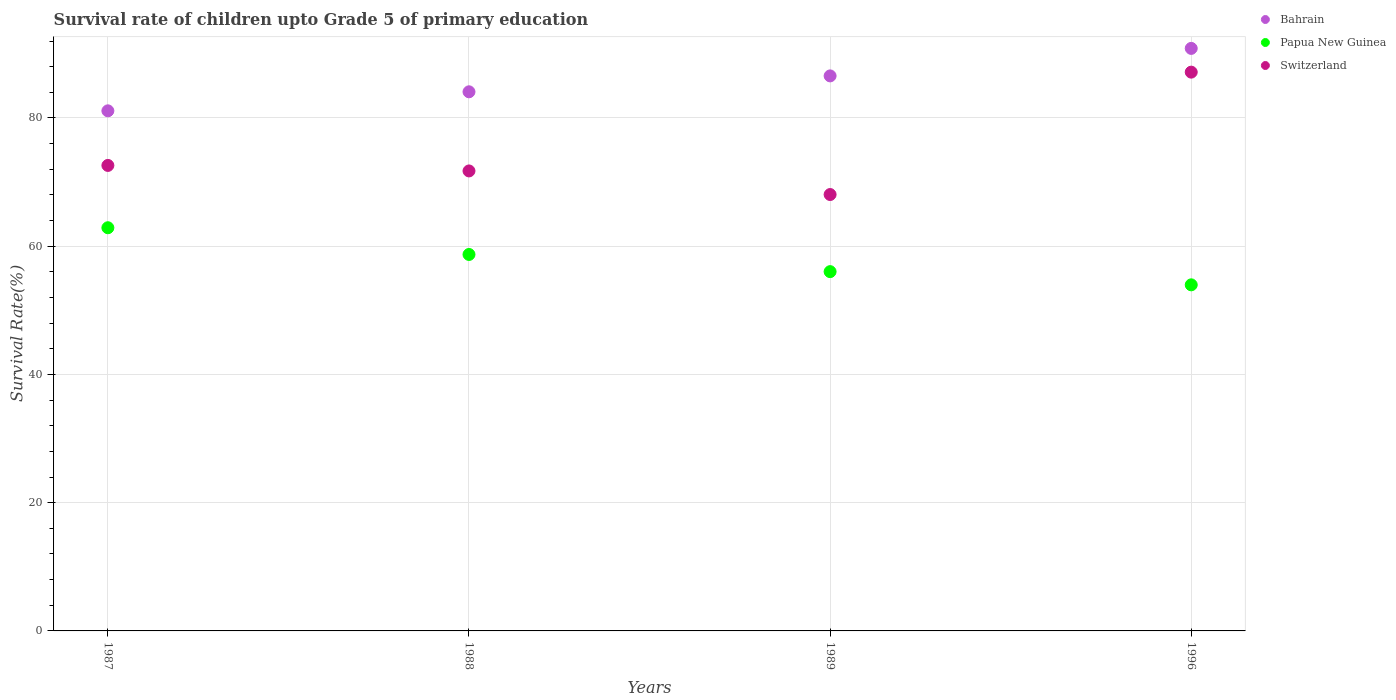How many different coloured dotlines are there?
Provide a succinct answer. 3. What is the survival rate of children in Papua New Guinea in 1996?
Your response must be concise. 53.97. Across all years, what is the maximum survival rate of children in Papua New Guinea?
Offer a very short reply. 62.88. Across all years, what is the minimum survival rate of children in Switzerland?
Offer a terse response. 68.06. In which year was the survival rate of children in Papua New Guinea maximum?
Ensure brevity in your answer.  1987. In which year was the survival rate of children in Papua New Guinea minimum?
Provide a succinct answer. 1996. What is the total survival rate of children in Switzerland in the graph?
Give a very brief answer. 299.54. What is the difference between the survival rate of children in Papua New Guinea in 1989 and that in 1996?
Keep it short and to the point. 2.06. What is the difference between the survival rate of children in Bahrain in 1988 and the survival rate of children in Papua New Guinea in 1987?
Provide a short and direct response. 21.2. What is the average survival rate of children in Switzerland per year?
Provide a succinct answer. 74.89. In the year 1987, what is the difference between the survival rate of children in Switzerland and survival rate of children in Bahrain?
Keep it short and to the point. -8.52. In how many years, is the survival rate of children in Bahrain greater than 4 %?
Offer a terse response. 4. What is the ratio of the survival rate of children in Bahrain in 1987 to that in 1988?
Your response must be concise. 0.96. Is the difference between the survival rate of children in Switzerland in 1988 and 1996 greater than the difference between the survival rate of children in Bahrain in 1988 and 1996?
Your answer should be very brief. No. What is the difference between the highest and the second highest survival rate of children in Switzerland?
Your answer should be very brief. 14.55. What is the difference between the highest and the lowest survival rate of children in Bahrain?
Give a very brief answer. 9.74. In how many years, is the survival rate of children in Papua New Guinea greater than the average survival rate of children in Papua New Guinea taken over all years?
Provide a short and direct response. 2. Is the sum of the survival rate of children in Switzerland in 1988 and 1989 greater than the maximum survival rate of children in Bahrain across all years?
Ensure brevity in your answer.  Yes. Does the survival rate of children in Switzerland monotonically increase over the years?
Make the answer very short. No. Does the graph contain any zero values?
Provide a short and direct response. No. Where does the legend appear in the graph?
Your answer should be compact. Top right. How many legend labels are there?
Make the answer very short. 3. What is the title of the graph?
Your answer should be compact. Survival rate of children upto Grade 5 of primary education. Does "Grenada" appear as one of the legend labels in the graph?
Ensure brevity in your answer.  No. What is the label or title of the Y-axis?
Make the answer very short. Survival Rate(%). What is the Survival Rate(%) of Bahrain in 1987?
Your response must be concise. 81.11. What is the Survival Rate(%) in Papua New Guinea in 1987?
Your answer should be very brief. 62.88. What is the Survival Rate(%) in Switzerland in 1987?
Offer a very short reply. 72.6. What is the Survival Rate(%) of Bahrain in 1988?
Offer a very short reply. 84.08. What is the Survival Rate(%) of Papua New Guinea in 1988?
Your response must be concise. 58.71. What is the Survival Rate(%) in Switzerland in 1988?
Offer a very short reply. 71.74. What is the Survival Rate(%) in Bahrain in 1989?
Give a very brief answer. 86.56. What is the Survival Rate(%) of Papua New Guinea in 1989?
Provide a short and direct response. 56.03. What is the Survival Rate(%) in Switzerland in 1989?
Your answer should be very brief. 68.06. What is the Survival Rate(%) of Bahrain in 1996?
Provide a short and direct response. 90.85. What is the Survival Rate(%) of Papua New Guinea in 1996?
Your response must be concise. 53.97. What is the Survival Rate(%) of Switzerland in 1996?
Your answer should be very brief. 87.15. Across all years, what is the maximum Survival Rate(%) in Bahrain?
Provide a succinct answer. 90.85. Across all years, what is the maximum Survival Rate(%) of Papua New Guinea?
Provide a short and direct response. 62.88. Across all years, what is the maximum Survival Rate(%) of Switzerland?
Make the answer very short. 87.15. Across all years, what is the minimum Survival Rate(%) in Bahrain?
Your response must be concise. 81.11. Across all years, what is the minimum Survival Rate(%) of Papua New Guinea?
Offer a terse response. 53.97. Across all years, what is the minimum Survival Rate(%) in Switzerland?
Offer a very short reply. 68.06. What is the total Survival Rate(%) in Bahrain in the graph?
Give a very brief answer. 342.6. What is the total Survival Rate(%) of Papua New Guinea in the graph?
Your response must be concise. 231.6. What is the total Survival Rate(%) in Switzerland in the graph?
Make the answer very short. 299.54. What is the difference between the Survival Rate(%) in Bahrain in 1987 and that in 1988?
Your answer should be compact. -2.97. What is the difference between the Survival Rate(%) in Papua New Guinea in 1987 and that in 1988?
Keep it short and to the point. 4.17. What is the difference between the Survival Rate(%) in Switzerland in 1987 and that in 1988?
Offer a terse response. 0.86. What is the difference between the Survival Rate(%) in Bahrain in 1987 and that in 1989?
Make the answer very short. -5.45. What is the difference between the Survival Rate(%) in Papua New Guinea in 1987 and that in 1989?
Provide a succinct answer. 6.85. What is the difference between the Survival Rate(%) in Switzerland in 1987 and that in 1989?
Offer a terse response. 4.54. What is the difference between the Survival Rate(%) of Bahrain in 1987 and that in 1996?
Keep it short and to the point. -9.74. What is the difference between the Survival Rate(%) of Papua New Guinea in 1987 and that in 1996?
Keep it short and to the point. 8.9. What is the difference between the Survival Rate(%) of Switzerland in 1987 and that in 1996?
Keep it short and to the point. -14.55. What is the difference between the Survival Rate(%) of Bahrain in 1988 and that in 1989?
Your answer should be very brief. -2.48. What is the difference between the Survival Rate(%) of Papua New Guinea in 1988 and that in 1989?
Keep it short and to the point. 2.68. What is the difference between the Survival Rate(%) in Switzerland in 1988 and that in 1989?
Keep it short and to the point. 3.68. What is the difference between the Survival Rate(%) in Bahrain in 1988 and that in 1996?
Give a very brief answer. -6.77. What is the difference between the Survival Rate(%) of Papua New Guinea in 1988 and that in 1996?
Keep it short and to the point. 4.74. What is the difference between the Survival Rate(%) of Switzerland in 1988 and that in 1996?
Keep it short and to the point. -15.41. What is the difference between the Survival Rate(%) in Bahrain in 1989 and that in 1996?
Offer a very short reply. -4.29. What is the difference between the Survival Rate(%) of Papua New Guinea in 1989 and that in 1996?
Keep it short and to the point. 2.06. What is the difference between the Survival Rate(%) of Switzerland in 1989 and that in 1996?
Offer a very short reply. -19.09. What is the difference between the Survival Rate(%) of Bahrain in 1987 and the Survival Rate(%) of Papua New Guinea in 1988?
Ensure brevity in your answer.  22.4. What is the difference between the Survival Rate(%) of Bahrain in 1987 and the Survival Rate(%) of Switzerland in 1988?
Make the answer very short. 9.37. What is the difference between the Survival Rate(%) in Papua New Guinea in 1987 and the Survival Rate(%) in Switzerland in 1988?
Your response must be concise. -8.86. What is the difference between the Survival Rate(%) in Bahrain in 1987 and the Survival Rate(%) in Papua New Guinea in 1989?
Offer a terse response. 25.08. What is the difference between the Survival Rate(%) of Bahrain in 1987 and the Survival Rate(%) of Switzerland in 1989?
Make the answer very short. 13.05. What is the difference between the Survival Rate(%) of Papua New Guinea in 1987 and the Survival Rate(%) of Switzerland in 1989?
Your answer should be compact. -5.18. What is the difference between the Survival Rate(%) in Bahrain in 1987 and the Survival Rate(%) in Papua New Guinea in 1996?
Provide a short and direct response. 27.14. What is the difference between the Survival Rate(%) in Bahrain in 1987 and the Survival Rate(%) in Switzerland in 1996?
Provide a succinct answer. -6.03. What is the difference between the Survival Rate(%) of Papua New Guinea in 1987 and the Survival Rate(%) of Switzerland in 1996?
Provide a short and direct response. -24.27. What is the difference between the Survival Rate(%) of Bahrain in 1988 and the Survival Rate(%) of Papua New Guinea in 1989?
Provide a succinct answer. 28.05. What is the difference between the Survival Rate(%) in Bahrain in 1988 and the Survival Rate(%) in Switzerland in 1989?
Ensure brevity in your answer.  16.02. What is the difference between the Survival Rate(%) in Papua New Guinea in 1988 and the Survival Rate(%) in Switzerland in 1989?
Provide a succinct answer. -9.35. What is the difference between the Survival Rate(%) in Bahrain in 1988 and the Survival Rate(%) in Papua New Guinea in 1996?
Your answer should be very brief. 30.11. What is the difference between the Survival Rate(%) of Bahrain in 1988 and the Survival Rate(%) of Switzerland in 1996?
Offer a terse response. -3.07. What is the difference between the Survival Rate(%) of Papua New Guinea in 1988 and the Survival Rate(%) of Switzerland in 1996?
Provide a succinct answer. -28.44. What is the difference between the Survival Rate(%) in Bahrain in 1989 and the Survival Rate(%) in Papua New Guinea in 1996?
Offer a terse response. 32.59. What is the difference between the Survival Rate(%) in Bahrain in 1989 and the Survival Rate(%) in Switzerland in 1996?
Your answer should be very brief. -0.59. What is the difference between the Survival Rate(%) in Papua New Guinea in 1989 and the Survival Rate(%) in Switzerland in 1996?
Your response must be concise. -31.11. What is the average Survival Rate(%) of Bahrain per year?
Your answer should be compact. 85.65. What is the average Survival Rate(%) in Papua New Guinea per year?
Your answer should be compact. 57.9. What is the average Survival Rate(%) of Switzerland per year?
Offer a very short reply. 74.89. In the year 1987, what is the difference between the Survival Rate(%) in Bahrain and Survival Rate(%) in Papua New Guinea?
Your answer should be very brief. 18.23. In the year 1987, what is the difference between the Survival Rate(%) in Bahrain and Survival Rate(%) in Switzerland?
Keep it short and to the point. 8.52. In the year 1987, what is the difference between the Survival Rate(%) in Papua New Guinea and Survival Rate(%) in Switzerland?
Offer a very short reply. -9.72. In the year 1988, what is the difference between the Survival Rate(%) in Bahrain and Survival Rate(%) in Papua New Guinea?
Provide a short and direct response. 25.37. In the year 1988, what is the difference between the Survival Rate(%) in Bahrain and Survival Rate(%) in Switzerland?
Your response must be concise. 12.34. In the year 1988, what is the difference between the Survival Rate(%) in Papua New Guinea and Survival Rate(%) in Switzerland?
Your answer should be very brief. -13.03. In the year 1989, what is the difference between the Survival Rate(%) of Bahrain and Survival Rate(%) of Papua New Guinea?
Make the answer very short. 30.53. In the year 1989, what is the difference between the Survival Rate(%) in Bahrain and Survival Rate(%) in Switzerland?
Offer a very short reply. 18.5. In the year 1989, what is the difference between the Survival Rate(%) in Papua New Guinea and Survival Rate(%) in Switzerland?
Your answer should be very brief. -12.03. In the year 1996, what is the difference between the Survival Rate(%) of Bahrain and Survival Rate(%) of Papua New Guinea?
Ensure brevity in your answer.  36.88. In the year 1996, what is the difference between the Survival Rate(%) in Bahrain and Survival Rate(%) in Switzerland?
Your answer should be very brief. 3.7. In the year 1996, what is the difference between the Survival Rate(%) of Papua New Guinea and Survival Rate(%) of Switzerland?
Give a very brief answer. -33.17. What is the ratio of the Survival Rate(%) in Bahrain in 1987 to that in 1988?
Offer a terse response. 0.96. What is the ratio of the Survival Rate(%) in Papua New Guinea in 1987 to that in 1988?
Give a very brief answer. 1.07. What is the ratio of the Survival Rate(%) in Switzerland in 1987 to that in 1988?
Ensure brevity in your answer.  1.01. What is the ratio of the Survival Rate(%) in Bahrain in 1987 to that in 1989?
Offer a very short reply. 0.94. What is the ratio of the Survival Rate(%) of Papua New Guinea in 1987 to that in 1989?
Your answer should be compact. 1.12. What is the ratio of the Survival Rate(%) of Switzerland in 1987 to that in 1989?
Give a very brief answer. 1.07. What is the ratio of the Survival Rate(%) of Bahrain in 1987 to that in 1996?
Make the answer very short. 0.89. What is the ratio of the Survival Rate(%) of Papua New Guinea in 1987 to that in 1996?
Provide a succinct answer. 1.17. What is the ratio of the Survival Rate(%) of Switzerland in 1987 to that in 1996?
Offer a terse response. 0.83. What is the ratio of the Survival Rate(%) of Bahrain in 1988 to that in 1989?
Give a very brief answer. 0.97. What is the ratio of the Survival Rate(%) of Papua New Guinea in 1988 to that in 1989?
Give a very brief answer. 1.05. What is the ratio of the Survival Rate(%) of Switzerland in 1988 to that in 1989?
Provide a succinct answer. 1.05. What is the ratio of the Survival Rate(%) of Bahrain in 1988 to that in 1996?
Provide a succinct answer. 0.93. What is the ratio of the Survival Rate(%) of Papua New Guinea in 1988 to that in 1996?
Keep it short and to the point. 1.09. What is the ratio of the Survival Rate(%) in Switzerland in 1988 to that in 1996?
Your answer should be compact. 0.82. What is the ratio of the Survival Rate(%) of Bahrain in 1989 to that in 1996?
Your answer should be compact. 0.95. What is the ratio of the Survival Rate(%) of Papua New Guinea in 1989 to that in 1996?
Provide a short and direct response. 1.04. What is the ratio of the Survival Rate(%) in Switzerland in 1989 to that in 1996?
Offer a terse response. 0.78. What is the difference between the highest and the second highest Survival Rate(%) of Bahrain?
Make the answer very short. 4.29. What is the difference between the highest and the second highest Survival Rate(%) of Papua New Guinea?
Ensure brevity in your answer.  4.17. What is the difference between the highest and the second highest Survival Rate(%) in Switzerland?
Offer a very short reply. 14.55. What is the difference between the highest and the lowest Survival Rate(%) in Bahrain?
Keep it short and to the point. 9.74. What is the difference between the highest and the lowest Survival Rate(%) in Papua New Guinea?
Provide a short and direct response. 8.9. What is the difference between the highest and the lowest Survival Rate(%) of Switzerland?
Your answer should be compact. 19.09. 